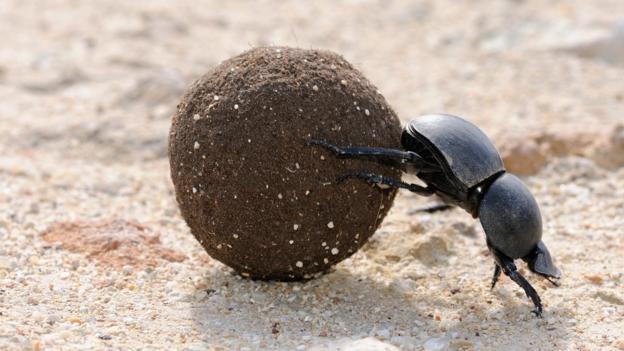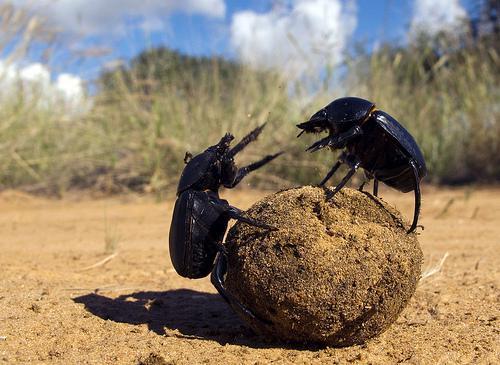The first image is the image on the left, the second image is the image on the right. Evaluate the accuracy of this statement regarding the images: "Images show a total of two beetles and two dung balls.". Is it true? Answer yes or no. No. 